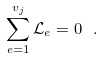Convert formula to latex. <formula><loc_0><loc_0><loc_500><loc_500>\sum _ { e = 1 } ^ { v _ { j } } \mathcal { L } _ { e } = 0 \ .</formula> 